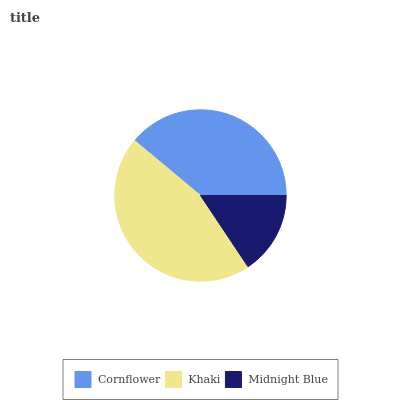Is Midnight Blue the minimum?
Answer yes or no. Yes. Is Khaki the maximum?
Answer yes or no. Yes. Is Khaki the minimum?
Answer yes or no. No. Is Midnight Blue the maximum?
Answer yes or no. No. Is Khaki greater than Midnight Blue?
Answer yes or no. Yes. Is Midnight Blue less than Khaki?
Answer yes or no. Yes. Is Midnight Blue greater than Khaki?
Answer yes or no. No. Is Khaki less than Midnight Blue?
Answer yes or no. No. Is Cornflower the high median?
Answer yes or no. Yes. Is Cornflower the low median?
Answer yes or no. Yes. Is Midnight Blue the high median?
Answer yes or no. No. Is Khaki the low median?
Answer yes or no. No. 